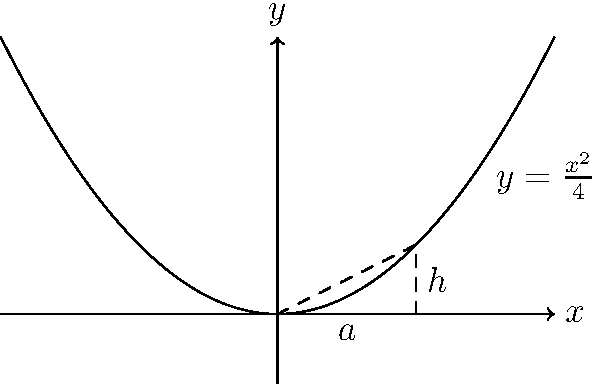A cryptocurrency's market cap growth can be modeled by the parabola $y = \frac{x^2}{4}$, where $x$ represents time in months and $y$ represents the market cap in billions of dollars. Calculate the area under this curve from $x = 0$ to $x = 2$, which represents the total market cap growth over a 2-month period. To find the area under the parabola, we need to use integration:

1) The area is given by the definite integral:
   $$A = \int_{0}^{2} \frac{x^2}{4} dx$$

2) Integrate the function:
   $$A = \left[\frac{x^3}{12}\right]_{0}^{2}$$

3) Evaluate the integral at the limits:
   $$A = \frac{2^3}{12} - \frac{0^3}{12}$$

4) Simplify:
   $$A = \frac{8}{12} - 0 = \frac{2}{3}$$

Therefore, the area under the curve, representing the total market cap growth over the 2-month period, is $\frac{2}{3}$ billion dollars.
Answer: $\frac{2}{3}$ billion dollars 